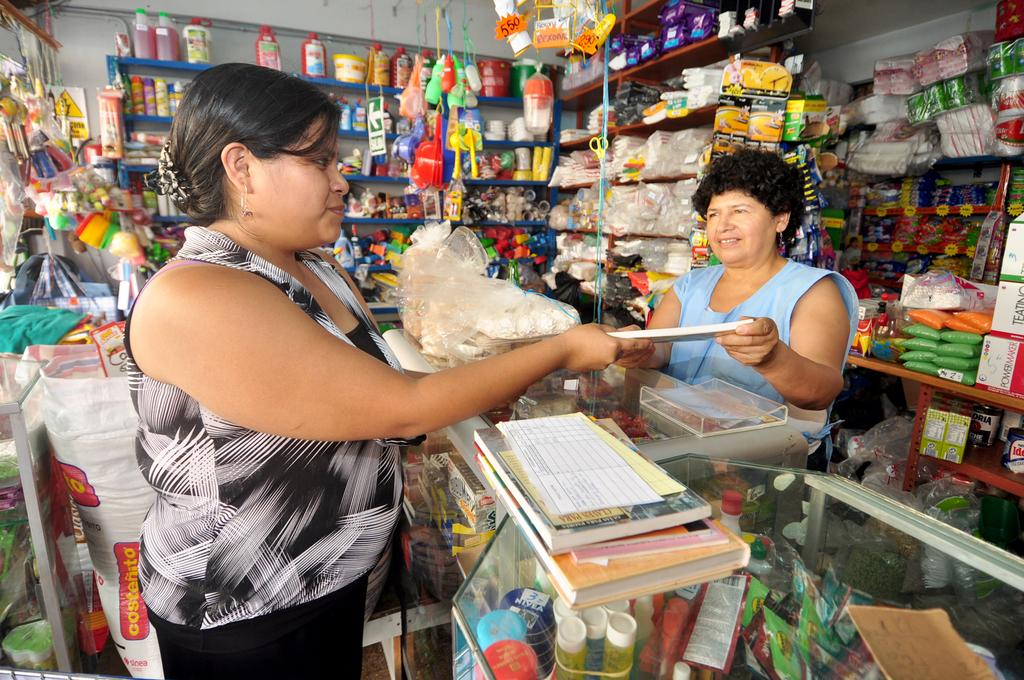<image>
Write a terse but informative summary of the picture. A bag with costenito printed on it is behind a women in a store. 